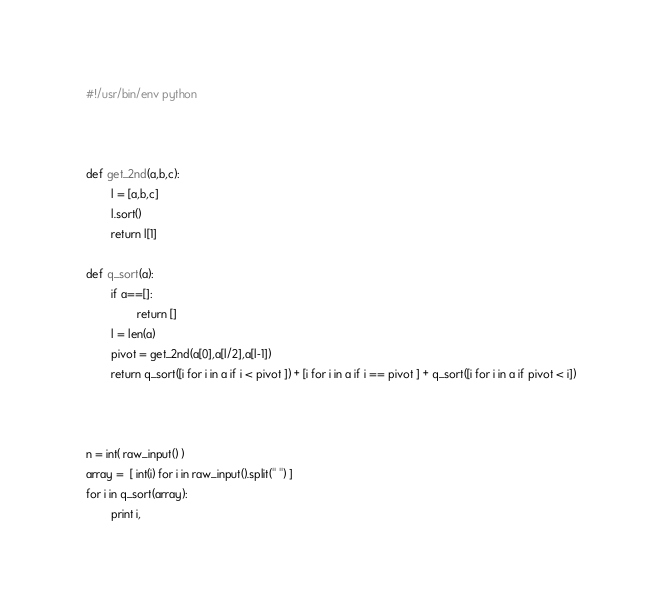<code> <loc_0><loc_0><loc_500><loc_500><_Python_>#!/usr/bin/env python



def get_2nd(a,b,c):
        l = [a,b,c]
        l.sort()
        return l[1]

def q_sort(a):
        if a==[]:
                return []
        l = len(a)
        pivot = get_2nd(a[0],a[l/2],a[l-1])
        return q_sort([i for i in a if i < pivot ]) + [i for i in a if i == pivot ] + q_sort([i for i in a if pivot < i])



n = int( raw_input() )
array =  [ int(i) for i in raw_input().split(" ") ]
for i in q_sort(array):
        print i,</code> 